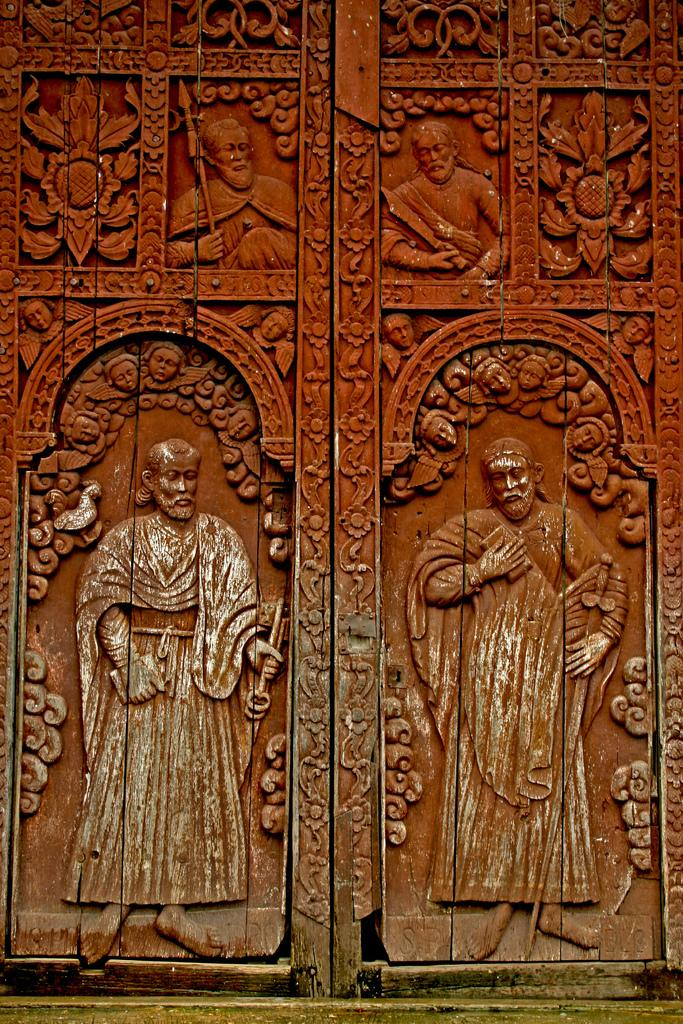What is a prominent feature in the picture? There is a door in the picture. Can you describe the door in more detail? The door has carving on it. What type of army is depicted on the door in the image? There is no army depicted on the door in the image; it only has carving. What type of carriage is parked next to the door in the image? There is no carriage present in the image; it only features a door with carving. 